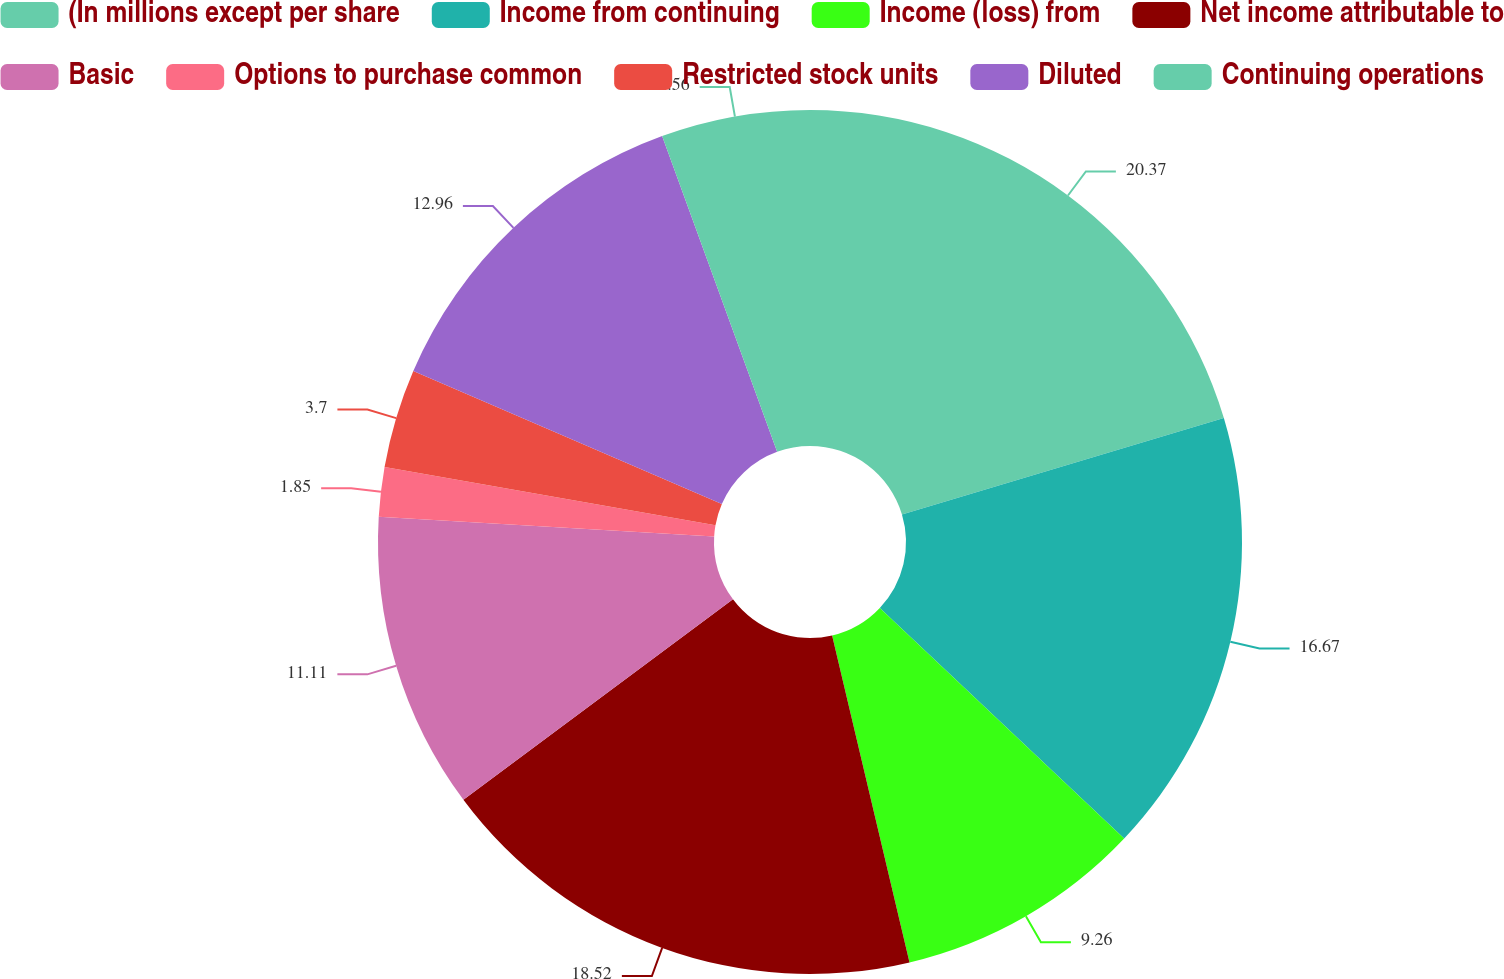Convert chart. <chart><loc_0><loc_0><loc_500><loc_500><pie_chart><fcel>(In millions except per share<fcel>Income from continuing<fcel>Income (loss) from<fcel>Net income attributable to<fcel>Basic<fcel>Options to purchase common<fcel>Restricted stock units<fcel>Diluted<fcel>Continuing operations<nl><fcel>20.37%<fcel>16.67%<fcel>9.26%<fcel>18.52%<fcel>11.11%<fcel>1.85%<fcel>3.7%<fcel>12.96%<fcel>5.56%<nl></chart> 